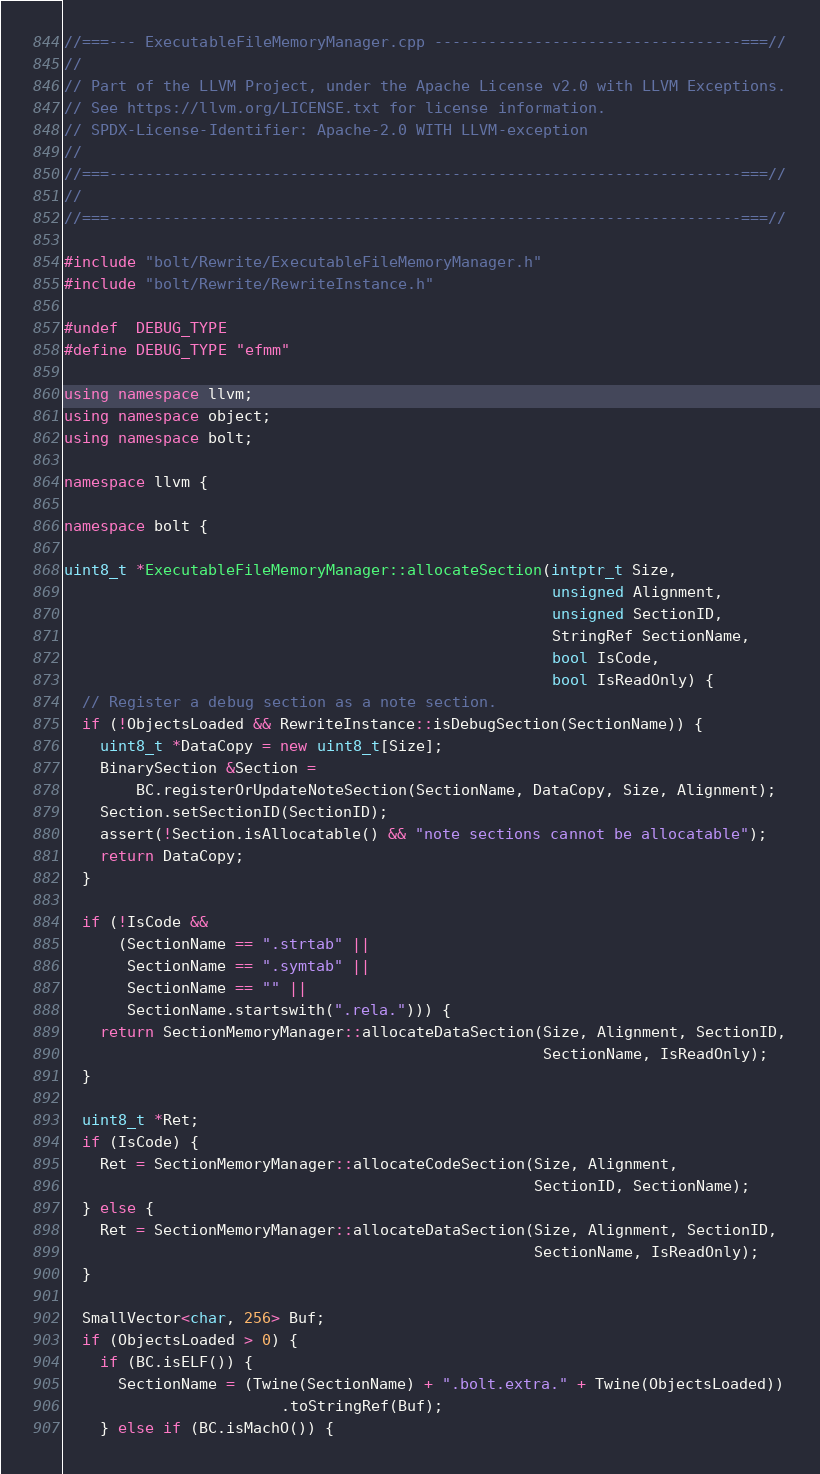Convert code to text. <code><loc_0><loc_0><loc_500><loc_500><_C++_>//===--- ExecutableFileMemoryManager.cpp ----------------------------------===//
//
// Part of the LLVM Project, under the Apache License v2.0 with LLVM Exceptions.
// See https://llvm.org/LICENSE.txt for license information.
// SPDX-License-Identifier: Apache-2.0 WITH LLVM-exception
//
//===----------------------------------------------------------------------===//
//
//===----------------------------------------------------------------------===//

#include "bolt/Rewrite/ExecutableFileMemoryManager.h"
#include "bolt/Rewrite/RewriteInstance.h"

#undef  DEBUG_TYPE
#define DEBUG_TYPE "efmm"

using namespace llvm;
using namespace object;
using namespace bolt;

namespace llvm {

namespace bolt {

uint8_t *ExecutableFileMemoryManager::allocateSection(intptr_t Size,
                                                      unsigned Alignment,
                                                      unsigned SectionID,
                                                      StringRef SectionName,
                                                      bool IsCode,
                                                      bool IsReadOnly) {
  // Register a debug section as a note section.
  if (!ObjectsLoaded && RewriteInstance::isDebugSection(SectionName)) {
    uint8_t *DataCopy = new uint8_t[Size];
    BinarySection &Section =
        BC.registerOrUpdateNoteSection(SectionName, DataCopy, Size, Alignment);
    Section.setSectionID(SectionID);
    assert(!Section.isAllocatable() && "note sections cannot be allocatable");
    return DataCopy;
  }

  if (!IsCode &&
      (SectionName == ".strtab" ||
       SectionName == ".symtab" ||
       SectionName == "" ||
       SectionName.startswith(".rela."))) {
    return SectionMemoryManager::allocateDataSection(Size, Alignment, SectionID,
                                                     SectionName, IsReadOnly);
  }

  uint8_t *Ret;
  if (IsCode) {
    Ret = SectionMemoryManager::allocateCodeSection(Size, Alignment,
                                                    SectionID, SectionName);
  } else {
    Ret = SectionMemoryManager::allocateDataSection(Size, Alignment, SectionID,
                                                    SectionName, IsReadOnly);
  }

  SmallVector<char, 256> Buf;
  if (ObjectsLoaded > 0) {
    if (BC.isELF()) {
      SectionName = (Twine(SectionName) + ".bolt.extra." + Twine(ObjectsLoaded))
                        .toStringRef(Buf);
    } else if (BC.isMachO()) {</code> 